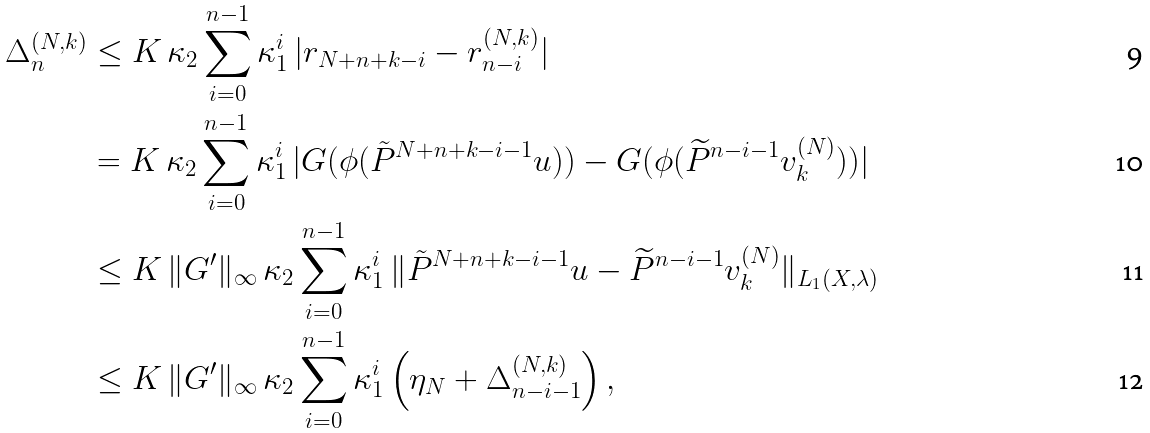Convert formula to latex. <formula><loc_0><loc_0><loc_500><loc_500>\Delta _ { n } ^ { ( N , k ) } & \leq K \, \kappa _ { 2 } \sum _ { i = 0 } ^ { n - 1 } \kappa _ { 1 } ^ { i } \, | r _ { N + n + k - i } - r _ { n - i } ^ { ( N , k ) } | \\ & = K \, \kappa _ { 2 } \sum _ { i = 0 } ^ { n - 1 } \kappa _ { 1 } ^ { i } \, | G ( \phi ( \tilde { P } ^ { N + n + k - i - 1 } u ) ) - G ( \phi ( \widetilde { P } ^ { n - i - 1 } v _ { k } ^ { ( N ) } ) ) | \\ & \leq K \, \| G ^ { \prime } \| _ { \infty } \, \kappa _ { 2 } \sum _ { i = 0 } ^ { n - 1 } \kappa _ { 1 } ^ { i } \, \| \tilde { P } ^ { N + n + k - i - 1 } u - \widetilde { P } ^ { n - i - 1 } v _ { k } ^ { ( N ) } \| _ { L _ { 1 } ( { X } , \lambda ) } \\ & \leq K \, \| G ^ { \prime } \| _ { \infty } \, \kappa _ { 2 } \sum _ { i = 0 } ^ { n - 1 } \kappa _ { 1 } ^ { i } \left ( \eta _ { N } + \Delta _ { n - i - 1 } ^ { ( N , k ) } \right ) ,</formula> 